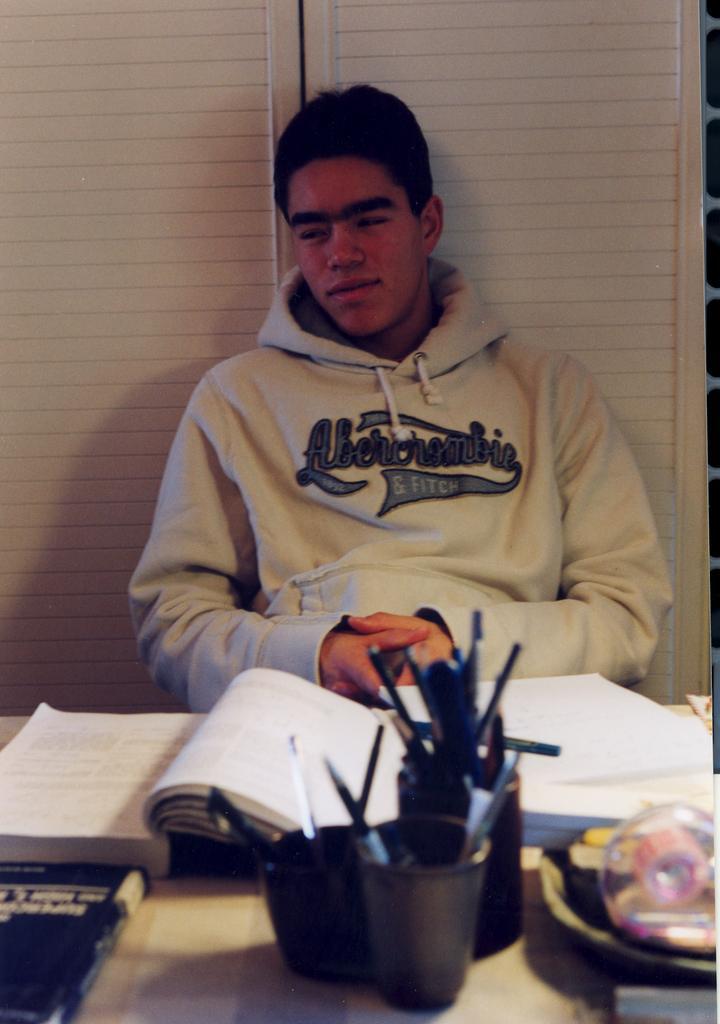Can you describe this image briefly? In this picture we can see a man is sitting. In front of the man, there is a table and on the table, there are books, pen stands and some other objects. Behind the man, there is a wall. 